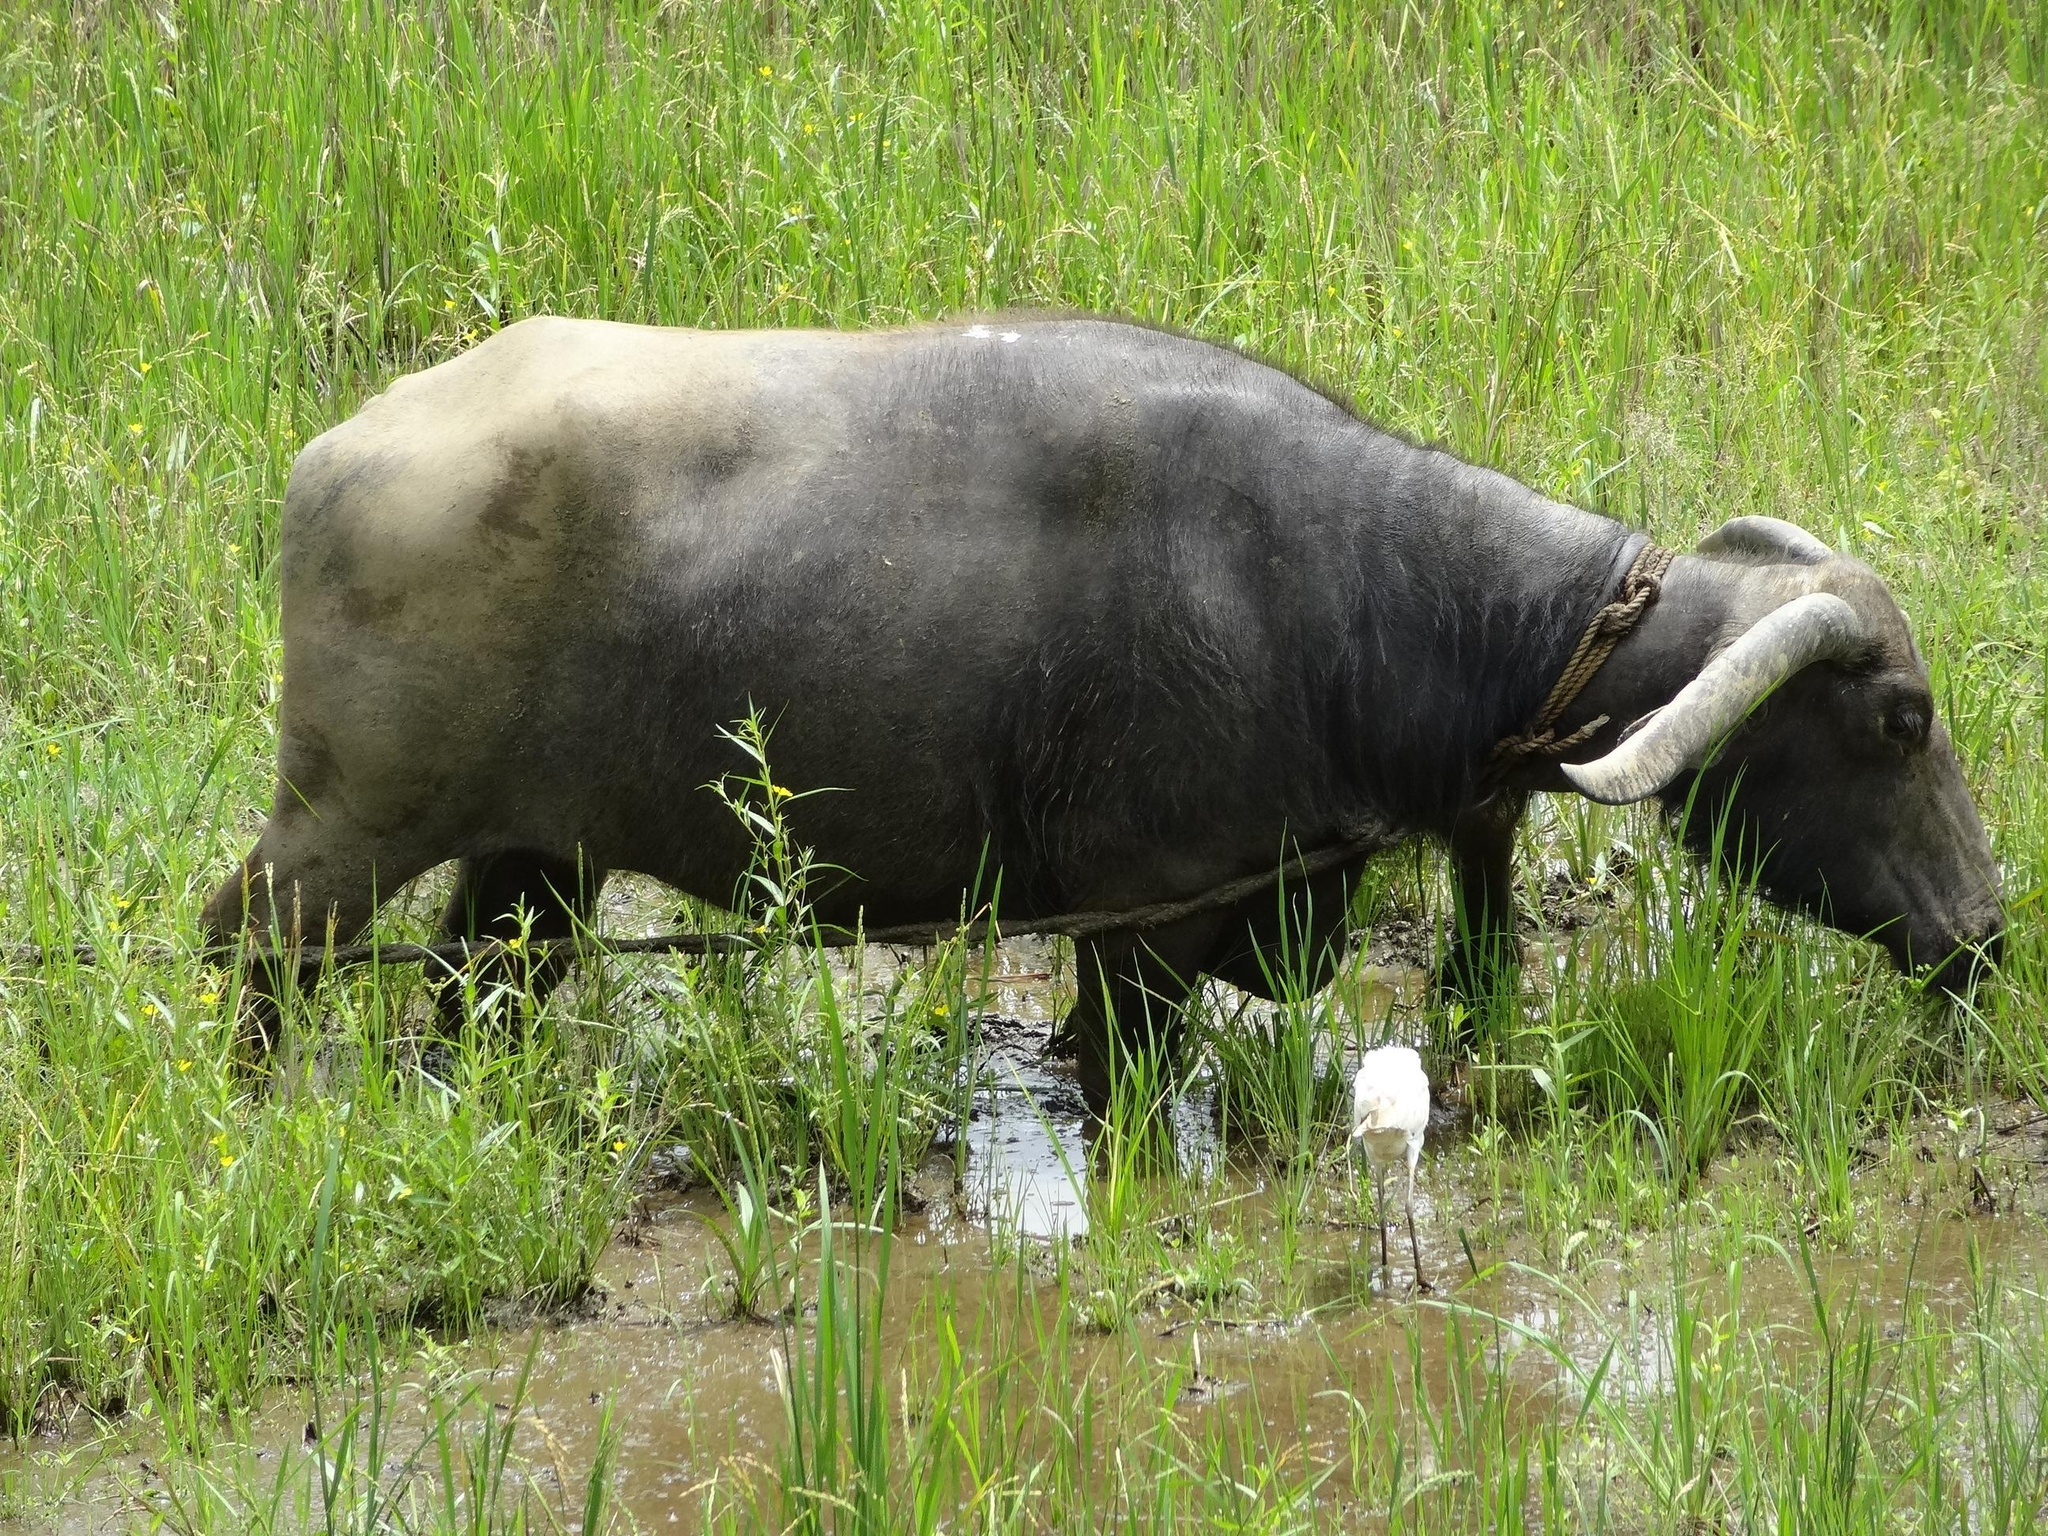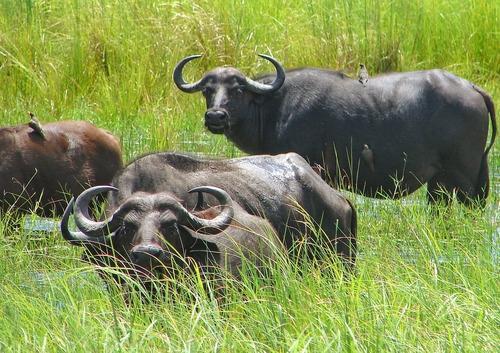The first image is the image on the left, the second image is the image on the right. For the images displayed, is the sentence "The bull on the left image is facing left." factually correct? Answer yes or no. No. 